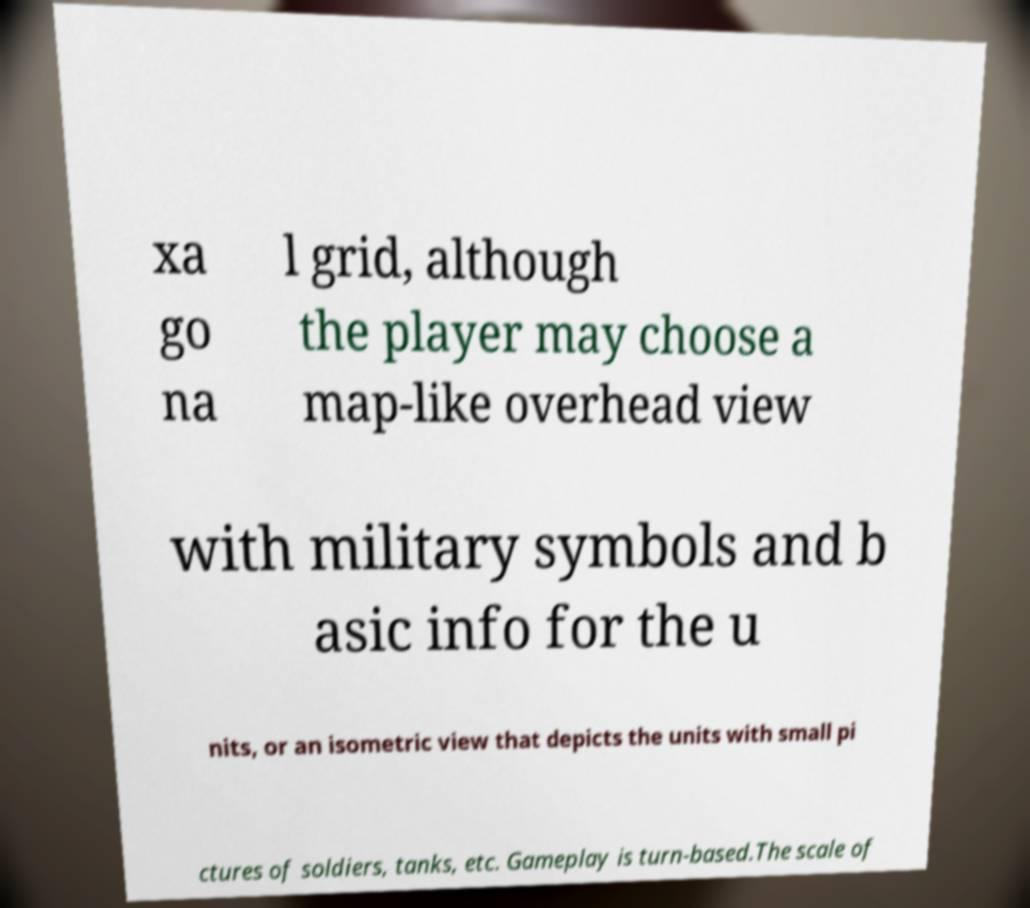Please read and relay the text visible in this image. What does it say? xa go na l grid, although the player may choose a map-like overhead view with military symbols and b asic info for the u nits, or an isometric view that depicts the units with small pi ctures of soldiers, tanks, etc. Gameplay is turn-based.The scale of 